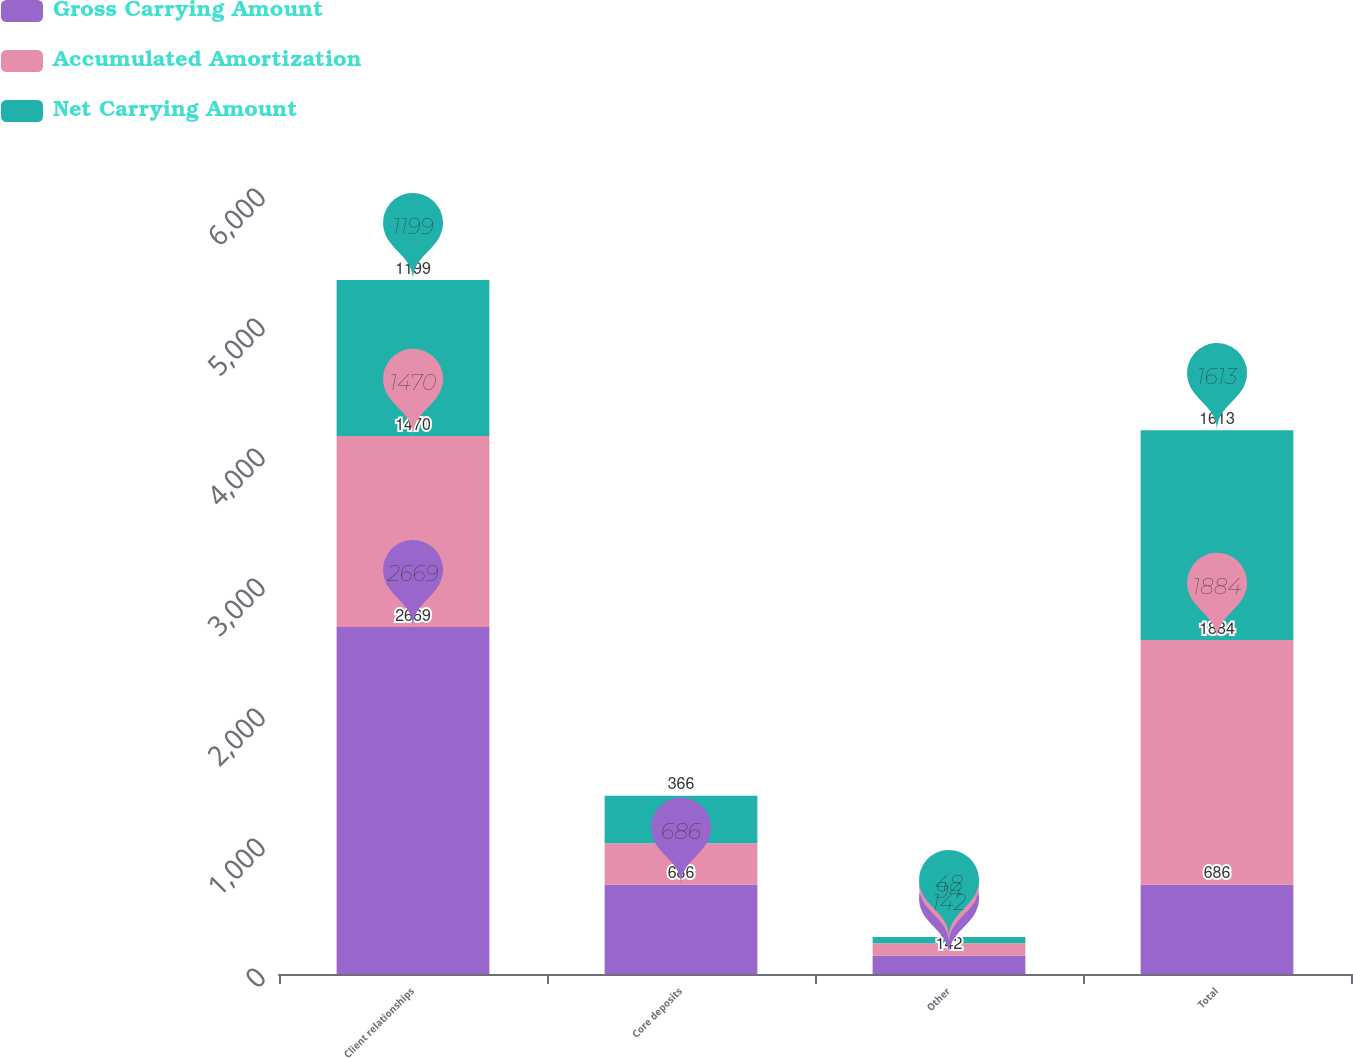Convert chart to OTSL. <chart><loc_0><loc_0><loc_500><loc_500><stacked_bar_chart><ecel><fcel>Client relationships<fcel>Core deposits<fcel>Other<fcel>Total<nl><fcel>Gross Carrying Amount<fcel>2669<fcel>686<fcel>142<fcel>686<nl><fcel>Accumulated Amortization<fcel>1470<fcel>320<fcel>94<fcel>1884<nl><fcel>Net Carrying Amount<fcel>1199<fcel>366<fcel>48<fcel>1613<nl></chart> 